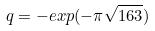<formula> <loc_0><loc_0><loc_500><loc_500>q = - e x p ( - \pi \sqrt { 1 6 3 } )</formula> 